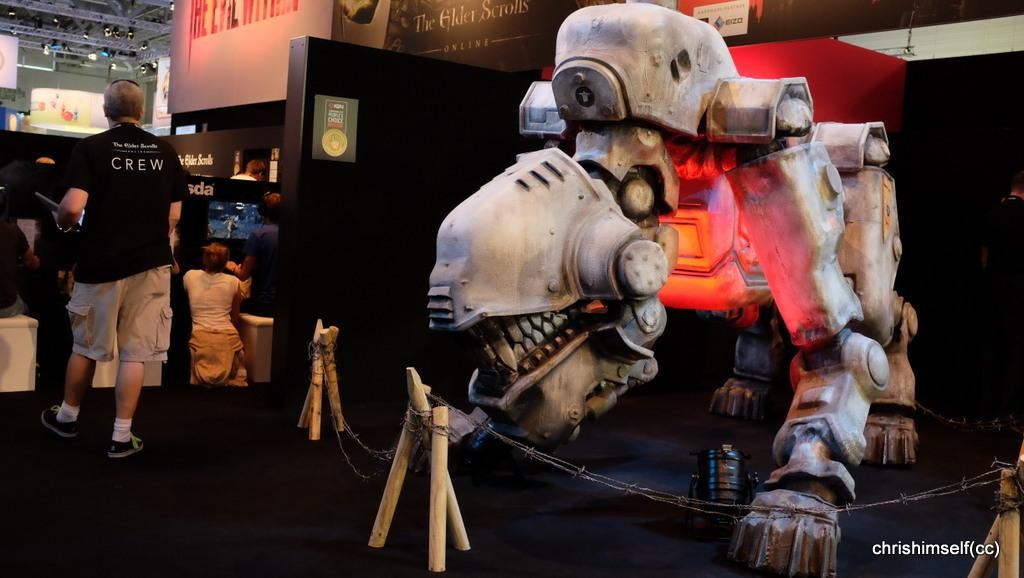What is the main object in the center of the image? There is a machine in the center of the image. What are the people on the left side of the image doing? There are persons sitting, walking, and standing on the left side of the image. What can be seen on the banners in the image? There are banners with text in the image. Can you tell me how many birds are perched on the machine in the image? There are no birds present in the image; it only features a machine, persons, and banners with text. 